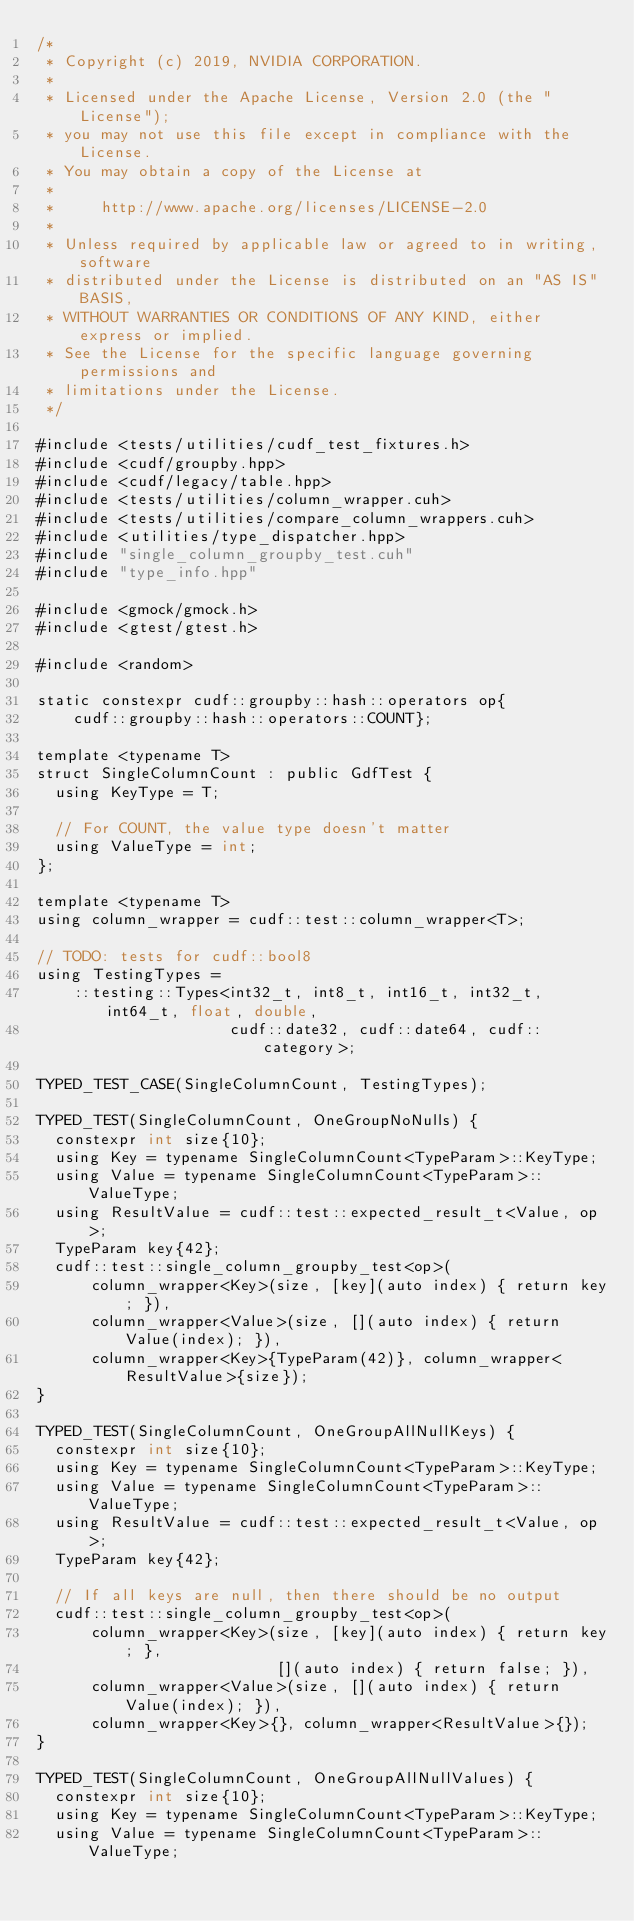<code> <loc_0><loc_0><loc_500><loc_500><_Cuda_>/*
 * Copyright (c) 2019, NVIDIA CORPORATION.
 *
 * Licensed under the Apache License, Version 2.0 (the "License");
 * you may not use this file except in compliance with the License.
 * You may obtain a copy of the License at
 *
 *     http://www.apache.org/licenses/LICENSE-2.0
 *
 * Unless required by applicable law or agreed to in writing, software
 * distributed under the License is distributed on an "AS IS" BASIS,
 * WITHOUT WARRANTIES OR CONDITIONS OF ANY KIND, either express or implied.
 * See the License for the specific language governing permissions and
 * limitations under the License.
 */

#include <tests/utilities/cudf_test_fixtures.h>
#include <cudf/groupby.hpp>
#include <cudf/legacy/table.hpp>
#include <tests/utilities/column_wrapper.cuh>
#include <tests/utilities/compare_column_wrappers.cuh>
#include <utilities/type_dispatcher.hpp>
#include "single_column_groupby_test.cuh"
#include "type_info.hpp"

#include <gmock/gmock.h>
#include <gtest/gtest.h>

#include <random>

static constexpr cudf::groupby::hash::operators op{
    cudf::groupby::hash::operators::COUNT};

template <typename T>
struct SingleColumnCount : public GdfTest {
  using KeyType = T;

  // For COUNT, the value type doesn't matter
  using ValueType = int;
};

template <typename T>
using column_wrapper = cudf::test::column_wrapper<T>;

// TODO: tests for cudf::bool8
using TestingTypes =
    ::testing::Types<int32_t, int8_t, int16_t, int32_t, int64_t, float, double,
                     cudf::date32, cudf::date64, cudf::category>;

TYPED_TEST_CASE(SingleColumnCount, TestingTypes);

TYPED_TEST(SingleColumnCount, OneGroupNoNulls) {
  constexpr int size{10};
  using Key = typename SingleColumnCount<TypeParam>::KeyType;
  using Value = typename SingleColumnCount<TypeParam>::ValueType;
  using ResultValue = cudf::test::expected_result_t<Value, op>;
  TypeParam key{42};
  cudf::test::single_column_groupby_test<op>(
      column_wrapper<Key>(size, [key](auto index) { return key; }),
      column_wrapper<Value>(size, [](auto index) { return Value(index); }),
      column_wrapper<Key>{TypeParam(42)}, column_wrapper<ResultValue>{size});
}

TYPED_TEST(SingleColumnCount, OneGroupAllNullKeys) {
  constexpr int size{10};
  using Key = typename SingleColumnCount<TypeParam>::KeyType;
  using Value = typename SingleColumnCount<TypeParam>::ValueType;
  using ResultValue = cudf::test::expected_result_t<Value, op>;
  TypeParam key{42};

  // If all keys are null, then there should be no output
  cudf::test::single_column_groupby_test<op>(
      column_wrapper<Key>(size, [key](auto index) { return key; },
                          [](auto index) { return false; }),
      column_wrapper<Value>(size, [](auto index) { return Value(index); }),
      column_wrapper<Key>{}, column_wrapper<ResultValue>{});
}

TYPED_TEST(SingleColumnCount, OneGroupAllNullValues) {
  constexpr int size{10};
  using Key = typename SingleColumnCount<TypeParam>::KeyType;
  using Value = typename SingleColumnCount<TypeParam>::ValueType;</code> 